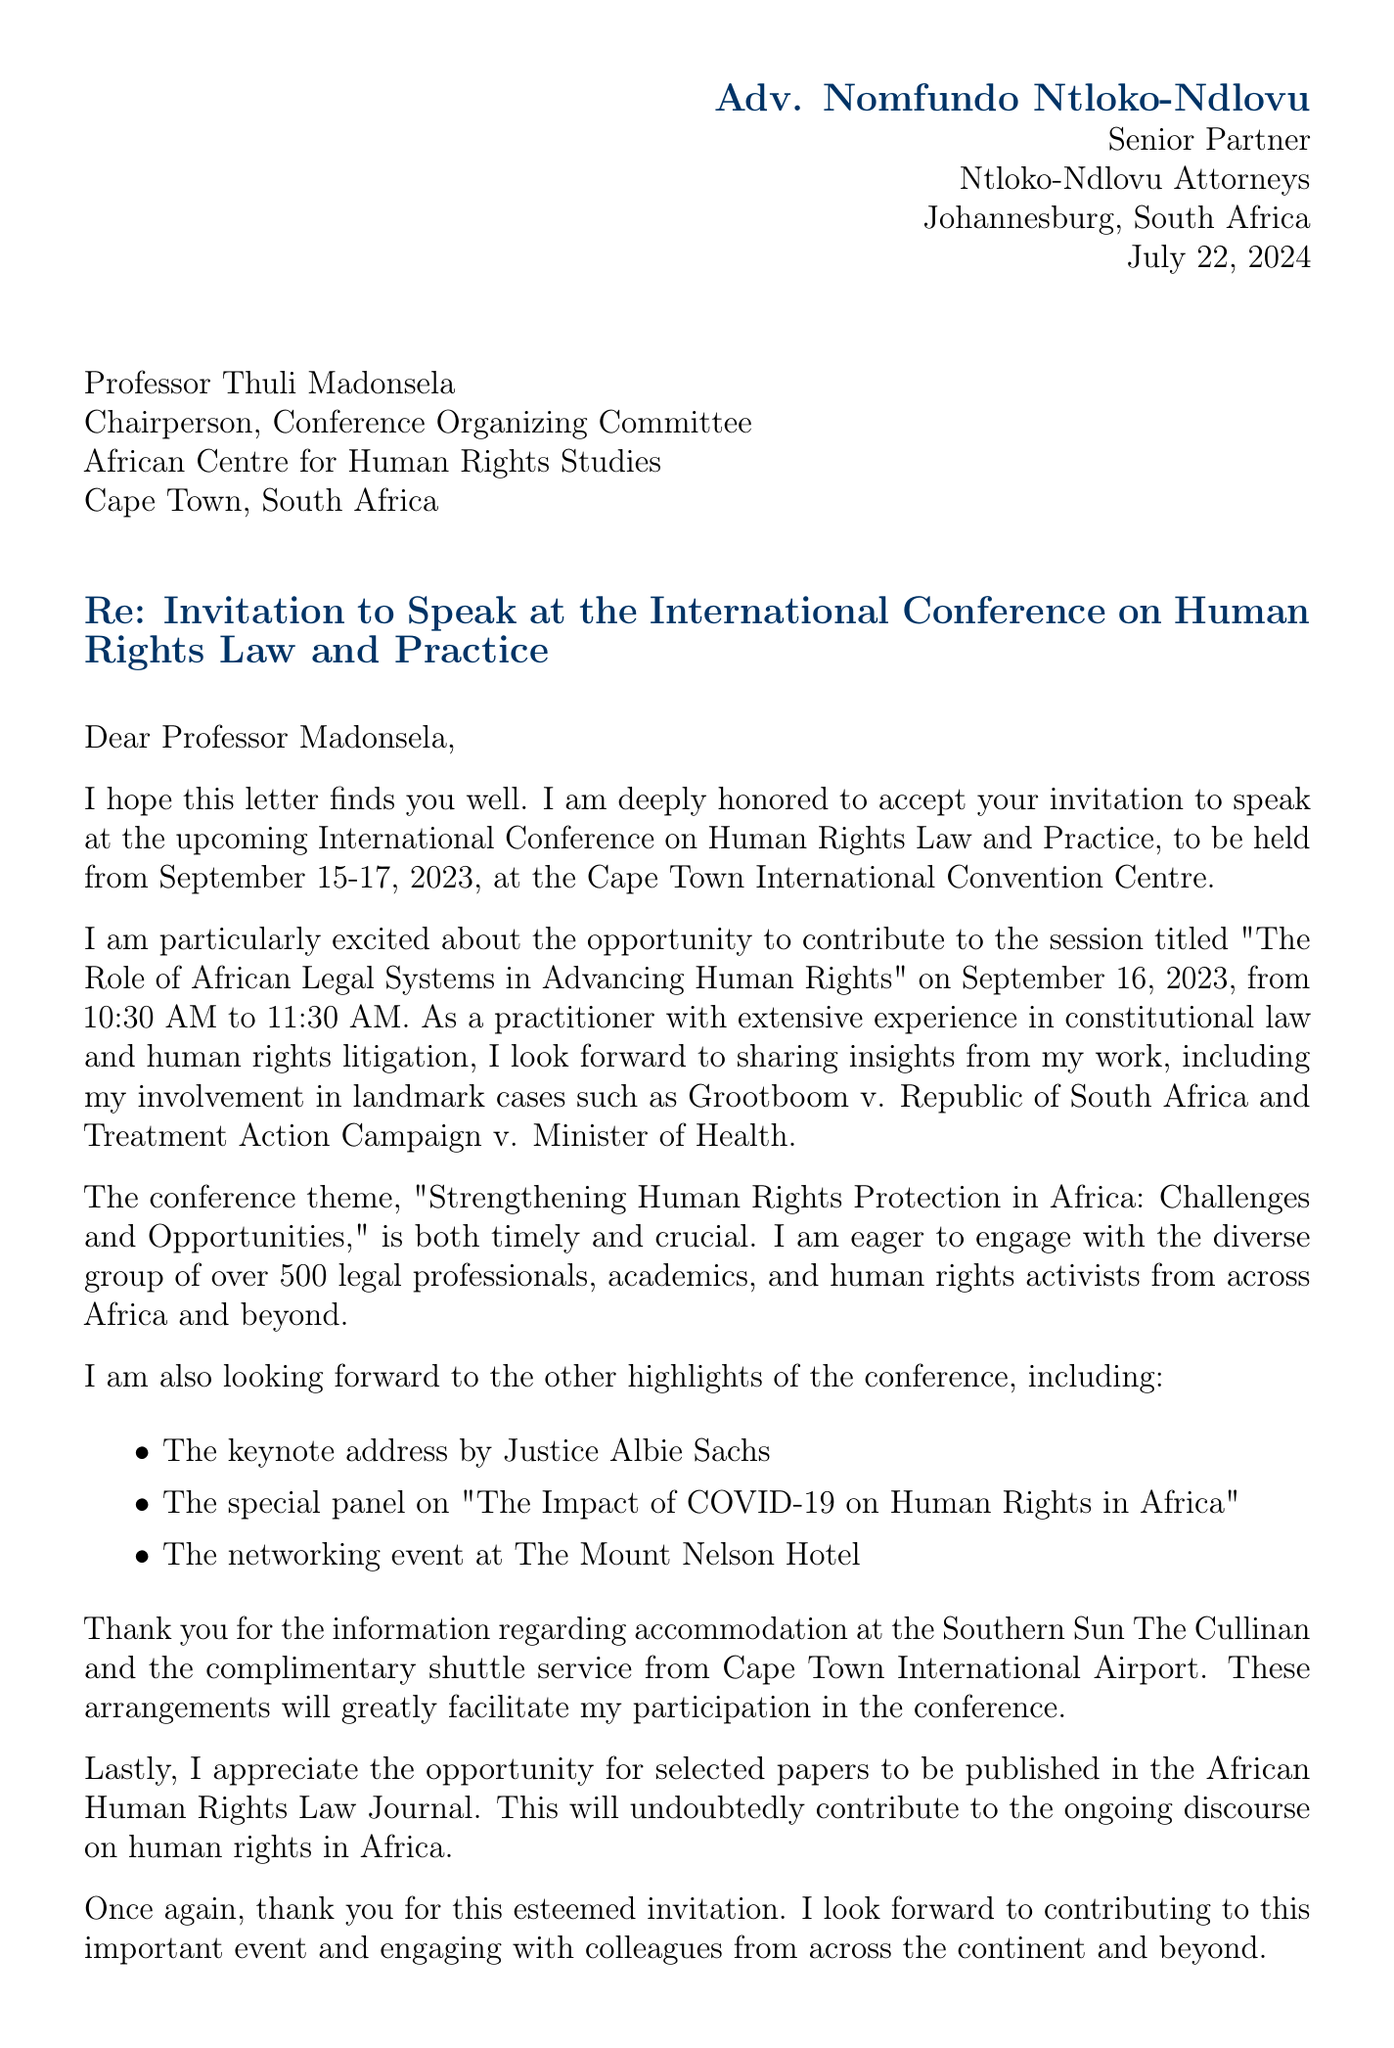What is the name of the conference? The name of the conference is explicitly mentioned in the letter.
Answer: International Conference on Human Rights Law and Practice Who is the keynote speaker? The letter provides specific information about the keynote speaker of the conference.
Answer: Justice Albie Sachs What are the dates of the conference? The letter clearly states the dates during which the conference will take place.
Answer: September 15-17, 2023 What is the title of the session Adv. Nomfundo Ntloko-Ndlovu will speak at? The title of the session is referenced directly in the invitation email.
Answer: The Role of African Legal Systems in Advancing Human Rights What is the duration of the speaking session? The letter outlines the format and timing of the speaking engagement.
Answer: 45-minute presentation followed by 15-minute Q&A What is the recommended hotel for accommodation? The letter specifies the hotel where attendees are suggested to stay.
Answer: Southern Sun The Cullinan How many attendees are expected at the conference? The expected number of attendees is mentioned in the additional information section of the document.
Answer: Over 500 What is the theme of the conference? The theme is provided as a central focus of the event in the letter.
Answer: Strengthening Human Rights Protection in Africa: Challenges and Opportunities What is Adv. Nomfundo Ntloko-Ndlovu's position? The letter identifies Adv. Nomfundo Ntloko-Ndlovu's professional role.
Answer: Senior Partner at Ntloko-Ndlovu Attorneys 